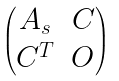Convert formula to latex. <formula><loc_0><loc_0><loc_500><loc_500>\begin{pmatrix} A _ { s } & C \\ C ^ { T } & O \end{pmatrix}</formula> 